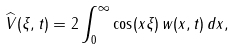Convert formula to latex. <formula><loc_0><loc_0><loc_500><loc_500>\widehat { V } ( \xi , t ) = 2 \int _ { 0 } ^ { \infty } \cos ( x \xi ) \, w ( x , t ) \, d x ,</formula> 